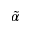<formula> <loc_0><loc_0><loc_500><loc_500>\tilde { \alpha }</formula> 